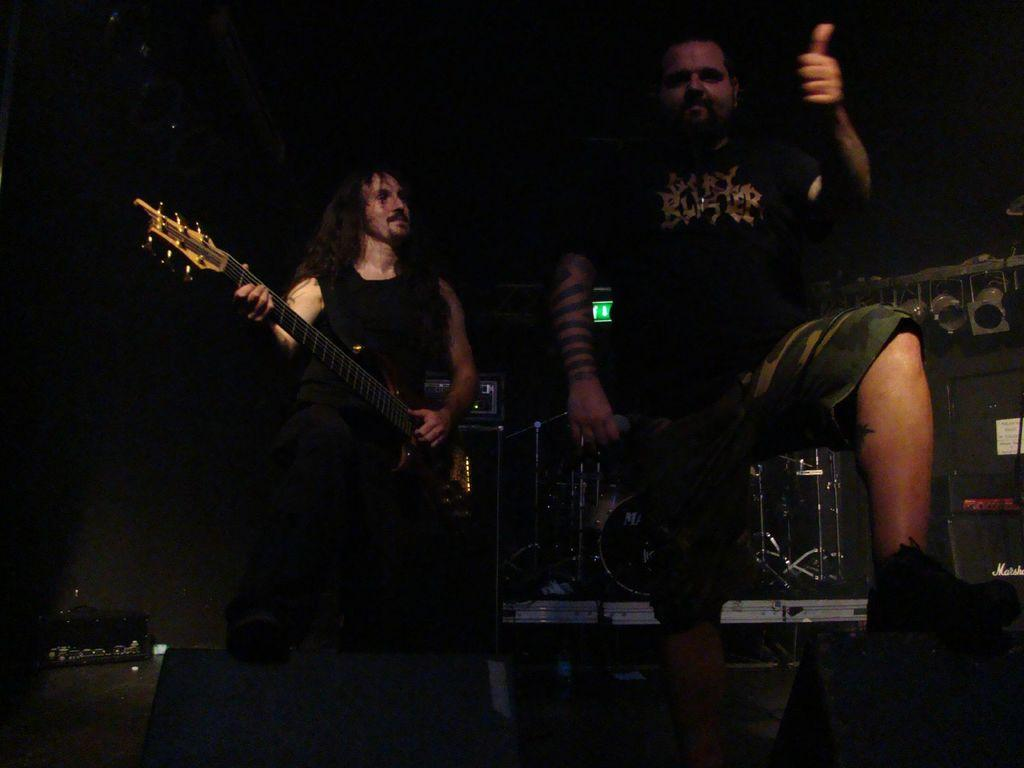What is the person on the left side of the image holding? The person on the left side of the image is holding a guitar. Can you describe the person standing beside the guitarist? The person standing beside the guitarist is holding a microphone. What musical instrument can be seen in the image besides the guitar? There are drums visible in the image. How many people are present in the image? There are two people present in the image. What type of vest is the guitarist wearing in the image? There is no mention of a vest in the image, so it cannot be determined if the guitarist is wearing one. 